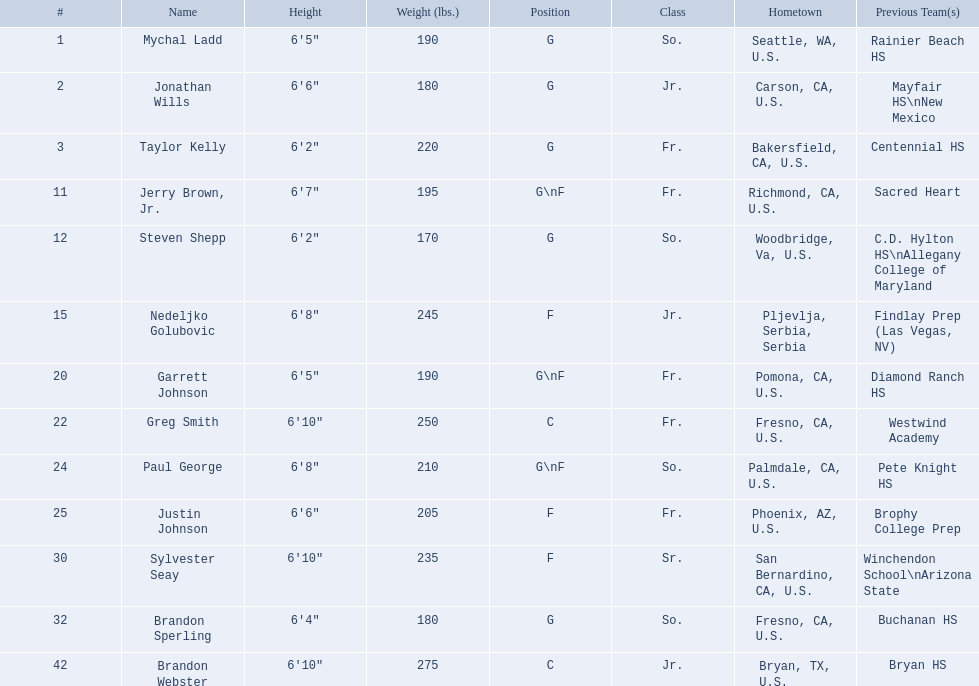Who played during the 2009-10 fresno state bulldogs men's basketball team? Mychal Ladd, Jonathan Wills, Taylor Kelly, Jerry Brown, Jr., Steven Shepp, Nedeljko Golubovic, Garrett Johnson, Greg Smith, Paul George, Justin Johnson, Sylvester Seay, Brandon Sperling, Brandon Webster. What was the position of each player? G, G, G, G\nF, G, F, G\nF, C, G\nF, F, F, G, C. And how tall were they? 6'5", 6'6", 6'2", 6'7", 6'2", 6'8", 6'5", 6'10", 6'8", 6'6", 6'10", 6'4", 6'10". Of these players, who was the shortest forward player? Justin Johnson. Which athletes are forwards? Nedeljko Golubovic, Paul George, Justin Johnson, Sylvester Seay. What are the heights of these athletes? Nedeljko Golubovic, 6'8", Paul George, 6'8", Justin Johnson, 6'6", Sylvester Seay, 6'10". Among these athletes, who is the shortest? Justin Johnson. 